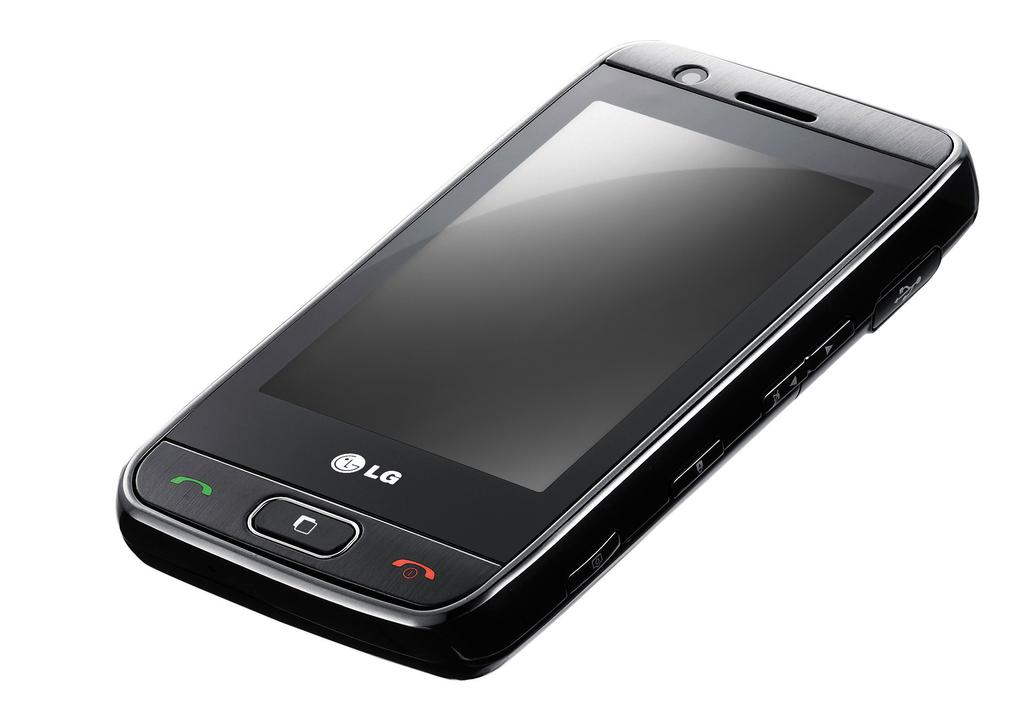Provide a one-sentence caption for the provided image. A black LG phone is angled up in front of a white background. 